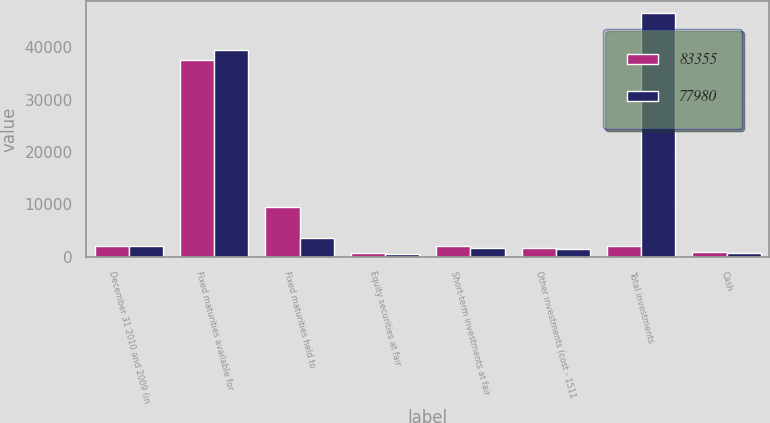Convert chart. <chart><loc_0><loc_0><loc_500><loc_500><stacked_bar_chart><ecel><fcel>December 31 2010 and 2009 (in<fcel>Fixed maturities available for<fcel>Fixed maturities held to<fcel>Equity securities at fair<fcel>Short-term investments at fair<fcel>Other investments (cost - 1511<fcel>Total investments<fcel>Cash<nl><fcel>83355<fcel>2010<fcel>37539<fcel>9501<fcel>692<fcel>1983<fcel>1692<fcel>1983<fcel>772<nl><fcel>77980<fcel>2009<fcel>39525<fcel>3481<fcel>467<fcel>1667<fcel>1375<fcel>46515<fcel>669<nl></chart> 